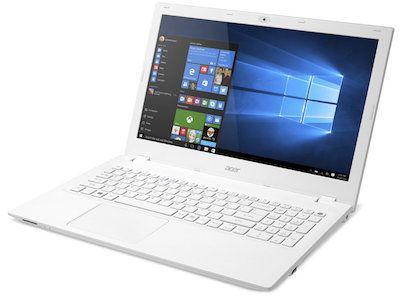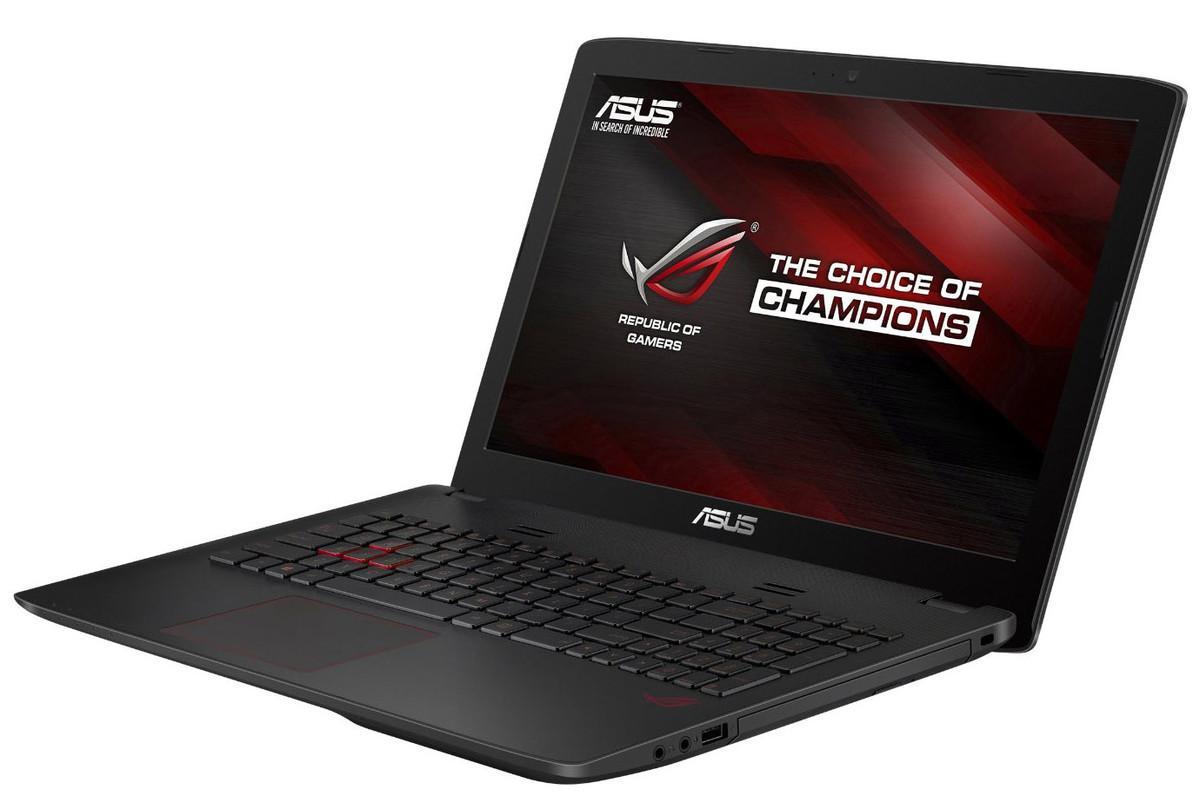The first image is the image on the left, the second image is the image on the right. Considering the images on both sides, is "The open laptop on the right is shown in an aerial view with a CD sticking out of the side, while the laptop on the left does not have a CD sticking out." valid? Answer yes or no. No. The first image is the image on the left, the second image is the image on the right. Given the left and right images, does the statement "The three gray laptops have an open disc drive on the right side of the keyboard." hold true? Answer yes or no. No. 